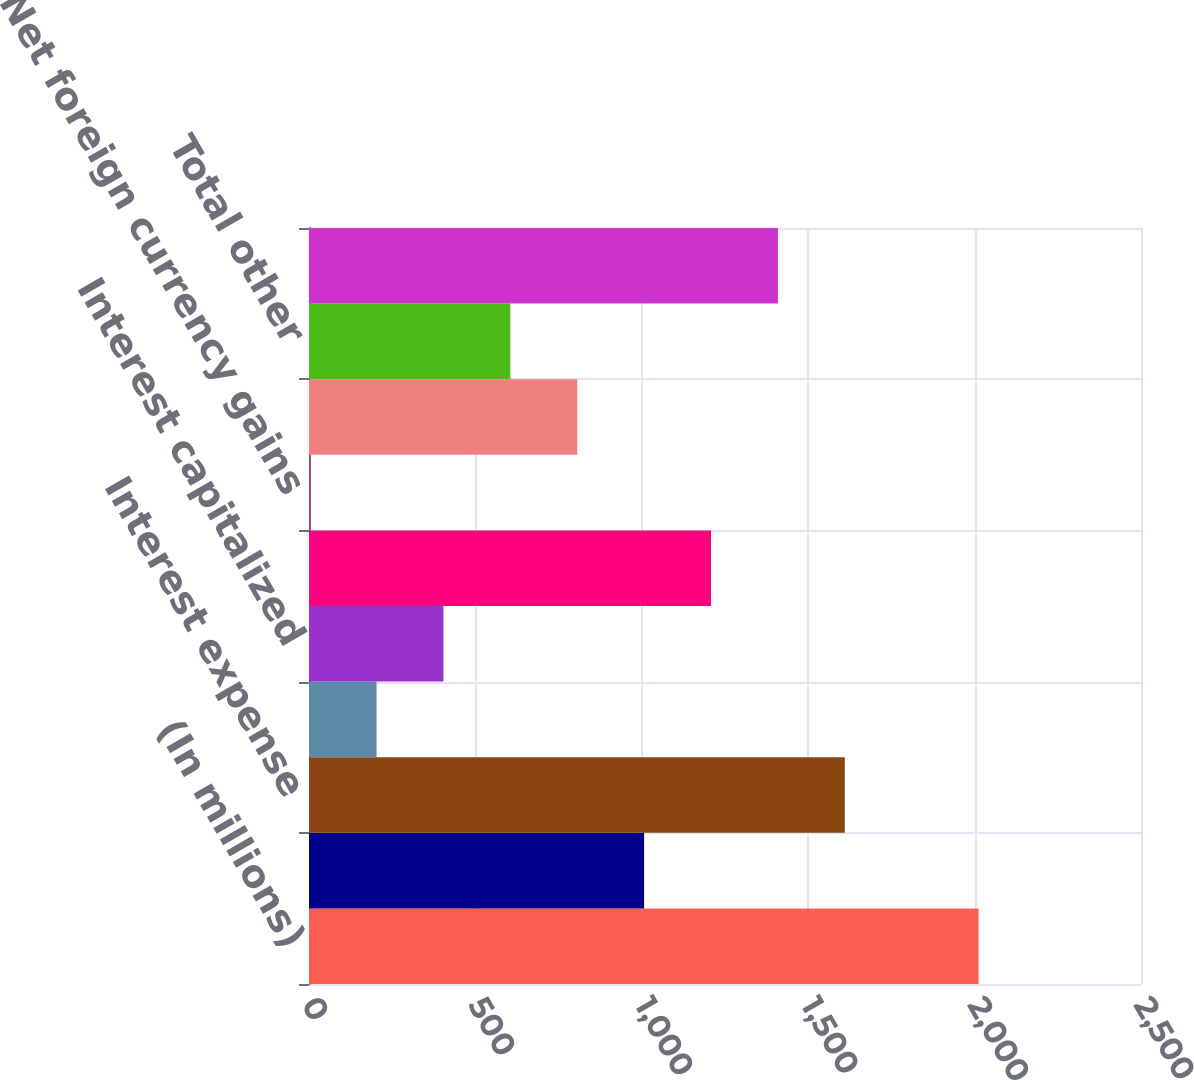Convert chart. <chart><loc_0><loc_0><loc_500><loc_500><bar_chart><fcel>(In millions)<fcel>Interest income<fcel>Interest expense<fcel>Income on interest rate swaps<fcel>Interest capitalized<fcel>Total interest<fcel>Net foreign currency gains<fcel>Other<fcel>Total other<fcel>Net interest and other<nl><fcel>2012<fcel>1007<fcel>1610<fcel>203<fcel>404<fcel>1208<fcel>2<fcel>806<fcel>605<fcel>1409<nl></chart> 